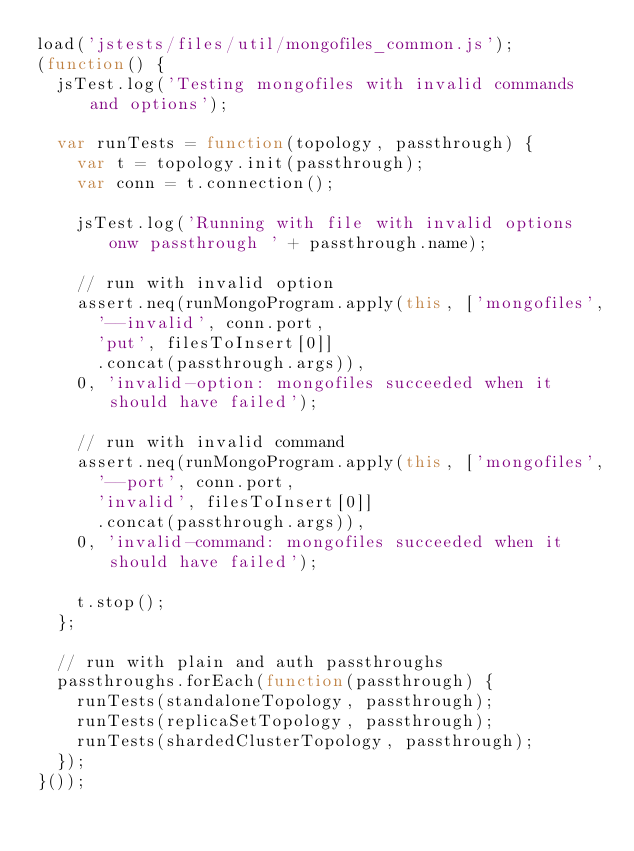<code> <loc_0><loc_0><loc_500><loc_500><_JavaScript_>load('jstests/files/util/mongofiles_common.js');
(function() {
  jsTest.log('Testing mongofiles with invalid commands and options');

  var runTests = function(topology, passthrough) {
    var t = topology.init(passthrough);
    var conn = t.connection();

    jsTest.log('Running with file with invalid options onw passthrough ' + passthrough.name);

    // run with invalid option
    assert.neq(runMongoProgram.apply(this, ['mongofiles',
      '--invalid', conn.port,
      'put', filesToInsert[0]]
      .concat(passthrough.args)),
    0, 'invalid-option: mongofiles succeeded when it should have failed');

    // run with invalid command
    assert.neq(runMongoProgram.apply(this, ['mongofiles',
      '--port', conn.port,
      'invalid', filesToInsert[0]]
      .concat(passthrough.args)),
    0, 'invalid-command: mongofiles succeeded when it should have failed');

    t.stop();
  };

  // run with plain and auth passthroughs
  passthroughs.forEach(function(passthrough) {
    runTests(standaloneTopology, passthrough);
    runTests(replicaSetTopology, passthrough);
    runTests(shardedClusterTopology, passthrough);
  });
}());
</code> 